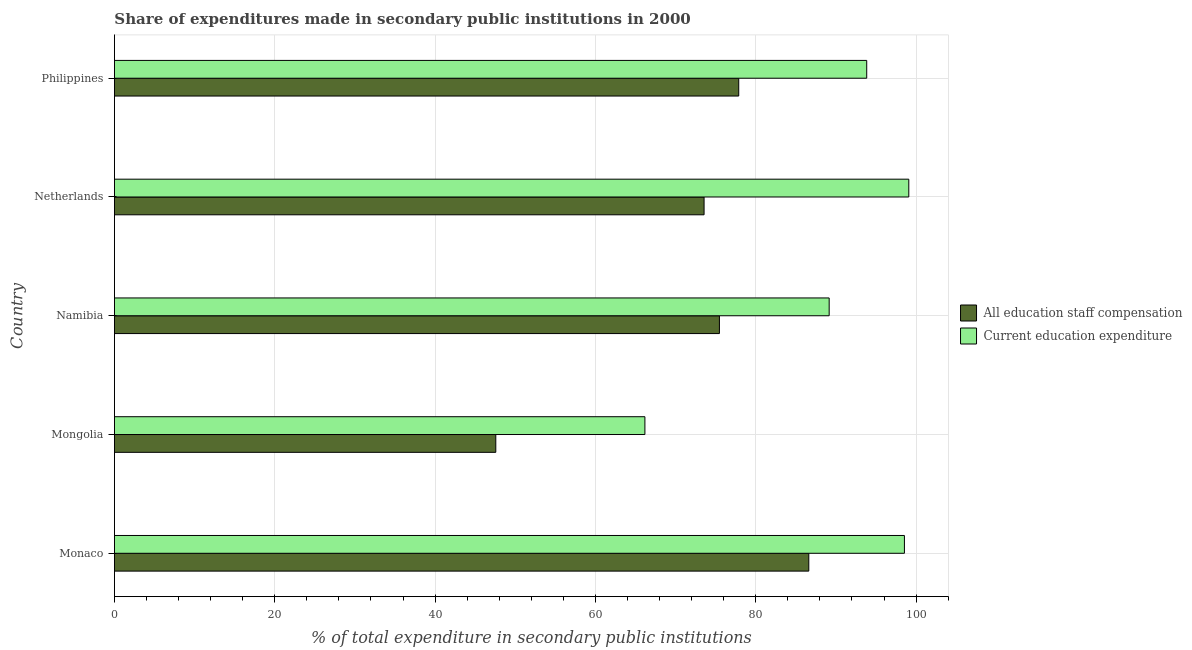How many different coloured bars are there?
Provide a short and direct response. 2. How many groups of bars are there?
Keep it short and to the point. 5. How many bars are there on the 1st tick from the top?
Make the answer very short. 2. How many bars are there on the 4th tick from the bottom?
Give a very brief answer. 2. What is the label of the 5th group of bars from the top?
Ensure brevity in your answer.  Monaco. What is the expenditure in education in Philippines?
Provide a succinct answer. 93.84. Across all countries, what is the maximum expenditure in staff compensation?
Your response must be concise. 86.62. Across all countries, what is the minimum expenditure in staff compensation?
Offer a very short reply. 47.57. In which country was the expenditure in staff compensation maximum?
Your response must be concise. Monaco. In which country was the expenditure in education minimum?
Provide a succinct answer. Mongolia. What is the total expenditure in staff compensation in the graph?
Your answer should be very brief. 361.08. What is the difference between the expenditure in staff compensation in Mongolia and that in Namibia?
Offer a terse response. -27.89. What is the difference between the expenditure in staff compensation in Mongolia and the expenditure in education in Netherlands?
Ensure brevity in your answer.  -51.52. What is the average expenditure in staff compensation per country?
Give a very brief answer. 72.22. What is the difference between the expenditure in education and expenditure in staff compensation in Mongolia?
Your answer should be very brief. 18.6. What is the ratio of the expenditure in staff compensation in Namibia to that in Netherlands?
Offer a very short reply. 1.03. Is the difference between the expenditure in staff compensation in Monaco and Netherlands greater than the difference between the expenditure in education in Monaco and Netherlands?
Keep it short and to the point. Yes. What is the difference between the highest and the second highest expenditure in staff compensation?
Give a very brief answer. 8.74. What is the difference between the highest and the lowest expenditure in staff compensation?
Provide a succinct answer. 39.04. In how many countries, is the expenditure in education greater than the average expenditure in education taken over all countries?
Offer a very short reply. 3. Is the sum of the expenditure in staff compensation in Netherlands and Philippines greater than the maximum expenditure in education across all countries?
Keep it short and to the point. Yes. What does the 1st bar from the top in Namibia represents?
Keep it short and to the point. Current education expenditure. What does the 1st bar from the bottom in Monaco represents?
Your response must be concise. All education staff compensation. Are all the bars in the graph horizontal?
Keep it short and to the point. Yes. How many countries are there in the graph?
Give a very brief answer. 5. What is the difference between two consecutive major ticks on the X-axis?
Offer a terse response. 20. Does the graph contain any zero values?
Give a very brief answer. No. Does the graph contain grids?
Make the answer very short. Yes. How many legend labels are there?
Ensure brevity in your answer.  2. How are the legend labels stacked?
Your answer should be compact. Vertical. What is the title of the graph?
Provide a succinct answer. Share of expenditures made in secondary public institutions in 2000. Does "Net National savings" appear as one of the legend labels in the graph?
Provide a short and direct response. No. What is the label or title of the X-axis?
Offer a terse response. % of total expenditure in secondary public institutions. What is the label or title of the Y-axis?
Offer a very short reply. Country. What is the % of total expenditure in secondary public institutions in All education staff compensation in Monaco?
Give a very brief answer. 86.62. What is the % of total expenditure in secondary public institutions in Current education expenditure in Monaco?
Make the answer very short. 98.54. What is the % of total expenditure in secondary public institutions of All education staff compensation in Mongolia?
Your response must be concise. 47.57. What is the % of total expenditure in secondary public institutions in Current education expenditure in Mongolia?
Your answer should be very brief. 66.17. What is the % of total expenditure in secondary public institutions in All education staff compensation in Namibia?
Offer a terse response. 75.47. What is the % of total expenditure in secondary public institutions in Current education expenditure in Namibia?
Provide a succinct answer. 89.16. What is the % of total expenditure in secondary public institutions of All education staff compensation in Netherlands?
Offer a very short reply. 73.55. What is the % of total expenditure in secondary public institutions in Current education expenditure in Netherlands?
Your response must be concise. 99.09. What is the % of total expenditure in secondary public institutions of All education staff compensation in Philippines?
Provide a short and direct response. 77.88. What is the % of total expenditure in secondary public institutions of Current education expenditure in Philippines?
Offer a terse response. 93.84. Across all countries, what is the maximum % of total expenditure in secondary public institutions in All education staff compensation?
Your answer should be compact. 86.62. Across all countries, what is the maximum % of total expenditure in secondary public institutions of Current education expenditure?
Offer a very short reply. 99.09. Across all countries, what is the minimum % of total expenditure in secondary public institutions of All education staff compensation?
Give a very brief answer. 47.57. Across all countries, what is the minimum % of total expenditure in secondary public institutions of Current education expenditure?
Give a very brief answer. 66.17. What is the total % of total expenditure in secondary public institutions of All education staff compensation in the graph?
Your answer should be very brief. 361.08. What is the total % of total expenditure in secondary public institutions in Current education expenditure in the graph?
Your response must be concise. 446.81. What is the difference between the % of total expenditure in secondary public institutions in All education staff compensation in Monaco and that in Mongolia?
Your response must be concise. 39.04. What is the difference between the % of total expenditure in secondary public institutions in Current education expenditure in Monaco and that in Mongolia?
Offer a terse response. 32.37. What is the difference between the % of total expenditure in secondary public institutions in All education staff compensation in Monaco and that in Namibia?
Give a very brief answer. 11.15. What is the difference between the % of total expenditure in secondary public institutions in Current education expenditure in Monaco and that in Namibia?
Your answer should be compact. 9.39. What is the difference between the % of total expenditure in secondary public institutions of All education staff compensation in Monaco and that in Netherlands?
Provide a succinct answer. 13.06. What is the difference between the % of total expenditure in secondary public institutions of Current education expenditure in Monaco and that in Netherlands?
Ensure brevity in your answer.  -0.55. What is the difference between the % of total expenditure in secondary public institutions in All education staff compensation in Monaco and that in Philippines?
Your response must be concise. 8.74. What is the difference between the % of total expenditure in secondary public institutions in Current education expenditure in Monaco and that in Philippines?
Make the answer very short. 4.7. What is the difference between the % of total expenditure in secondary public institutions in All education staff compensation in Mongolia and that in Namibia?
Give a very brief answer. -27.9. What is the difference between the % of total expenditure in secondary public institutions in Current education expenditure in Mongolia and that in Namibia?
Offer a terse response. -22.99. What is the difference between the % of total expenditure in secondary public institutions of All education staff compensation in Mongolia and that in Netherlands?
Your response must be concise. -25.98. What is the difference between the % of total expenditure in secondary public institutions of Current education expenditure in Mongolia and that in Netherlands?
Provide a short and direct response. -32.92. What is the difference between the % of total expenditure in secondary public institutions of All education staff compensation in Mongolia and that in Philippines?
Give a very brief answer. -30.3. What is the difference between the % of total expenditure in secondary public institutions of Current education expenditure in Mongolia and that in Philippines?
Ensure brevity in your answer.  -27.67. What is the difference between the % of total expenditure in secondary public institutions in All education staff compensation in Namibia and that in Netherlands?
Offer a terse response. 1.91. What is the difference between the % of total expenditure in secondary public institutions in Current education expenditure in Namibia and that in Netherlands?
Offer a very short reply. -9.93. What is the difference between the % of total expenditure in secondary public institutions of All education staff compensation in Namibia and that in Philippines?
Your response must be concise. -2.41. What is the difference between the % of total expenditure in secondary public institutions in Current education expenditure in Namibia and that in Philippines?
Offer a very short reply. -4.68. What is the difference between the % of total expenditure in secondary public institutions of All education staff compensation in Netherlands and that in Philippines?
Offer a terse response. -4.32. What is the difference between the % of total expenditure in secondary public institutions of Current education expenditure in Netherlands and that in Philippines?
Keep it short and to the point. 5.25. What is the difference between the % of total expenditure in secondary public institutions in All education staff compensation in Monaco and the % of total expenditure in secondary public institutions in Current education expenditure in Mongolia?
Your answer should be very brief. 20.44. What is the difference between the % of total expenditure in secondary public institutions of All education staff compensation in Monaco and the % of total expenditure in secondary public institutions of Current education expenditure in Namibia?
Your answer should be compact. -2.54. What is the difference between the % of total expenditure in secondary public institutions of All education staff compensation in Monaco and the % of total expenditure in secondary public institutions of Current education expenditure in Netherlands?
Give a very brief answer. -12.47. What is the difference between the % of total expenditure in secondary public institutions in All education staff compensation in Monaco and the % of total expenditure in secondary public institutions in Current education expenditure in Philippines?
Keep it short and to the point. -7.23. What is the difference between the % of total expenditure in secondary public institutions in All education staff compensation in Mongolia and the % of total expenditure in secondary public institutions in Current education expenditure in Namibia?
Give a very brief answer. -41.59. What is the difference between the % of total expenditure in secondary public institutions in All education staff compensation in Mongolia and the % of total expenditure in secondary public institutions in Current education expenditure in Netherlands?
Ensure brevity in your answer.  -51.52. What is the difference between the % of total expenditure in secondary public institutions in All education staff compensation in Mongolia and the % of total expenditure in secondary public institutions in Current education expenditure in Philippines?
Your answer should be very brief. -46.27. What is the difference between the % of total expenditure in secondary public institutions of All education staff compensation in Namibia and the % of total expenditure in secondary public institutions of Current education expenditure in Netherlands?
Your answer should be compact. -23.62. What is the difference between the % of total expenditure in secondary public institutions in All education staff compensation in Namibia and the % of total expenditure in secondary public institutions in Current education expenditure in Philippines?
Offer a very short reply. -18.37. What is the difference between the % of total expenditure in secondary public institutions of All education staff compensation in Netherlands and the % of total expenditure in secondary public institutions of Current education expenditure in Philippines?
Provide a short and direct response. -20.29. What is the average % of total expenditure in secondary public institutions in All education staff compensation per country?
Give a very brief answer. 72.22. What is the average % of total expenditure in secondary public institutions of Current education expenditure per country?
Your response must be concise. 89.36. What is the difference between the % of total expenditure in secondary public institutions in All education staff compensation and % of total expenditure in secondary public institutions in Current education expenditure in Monaco?
Offer a terse response. -11.93. What is the difference between the % of total expenditure in secondary public institutions in All education staff compensation and % of total expenditure in secondary public institutions in Current education expenditure in Mongolia?
Offer a very short reply. -18.6. What is the difference between the % of total expenditure in secondary public institutions in All education staff compensation and % of total expenditure in secondary public institutions in Current education expenditure in Namibia?
Provide a short and direct response. -13.69. What is the difference between the % of total expenditure in secondary public institutions of All education staff compensation and % of total expenditure in secondary public institutions of Current education expenditure in Netherlands?
Ensure brevity in your answer.  -25.54. What is the difference between the % of total expenditure in secondary public institutions of All education staff compensation and % of total expenditure in secondary public institutions of Current education expenditure in Philippines?
Your answer should be compact. -15.97. What is the ratio of the % of total expenditure in secondary public institutions of All education staff compensation in Monaco to that in Mongolia?
Ensure brevity in your answer.  1.82. What is the ratio of the % of total expenditure in secondary public institutions in Current education expenditure in Monaco to that in Mongolia?
Make the answer very short. 1.49. What is the ratio of the % of total expenditure in secondary public institutions in All education staff compensation in Monaco to that in Namibia?
Ensure brevity in your answer.  1.15. What is the ratio of the % of total expenditure in secondary public institutions of Current education expenditure in Monaco to that in Namibia?
Your answer should be compact. 1.11. What is the ratio of the % of total expenditure in secondary public institutions of All education staff compensation in Monaco to that in Netherlands?
Provide a succinct answer. 1.18. What is the ratio of the % of total expenditure in secondary public institutions in Current education expenditure in Monaco to that in Netherlands?
Offer a very short reply. 0.99. What is the ratio of the % of total expenditure in secondary public institutions in All education staff compensation in Monaco to that in Philippines?
Provide a short and direct response. 1.11. What is the ratio of the % of total expenditure in secondary public institutions of Current education expenditure in Monaco to that in Philippines?
Provide a succinct answer. 1.05. What is the ratio of the % of total expenditure in secondary public institutions of All education staff compensation in Mongolia to that in Namibia?
Keep it short and to the point. 0.63. What is the ratio of the % of total expenditure in secondary public institutions in Current education expenditure in Mongolia to that in Namibia?
Your response must be concise. 0.74. What is the ratio of the % of total expenditure in secondary public institutions of All education staff compensation in Mongolia to that in Netherlands?
Provide a succinct answer. 0.65. What is the ratio of the % of total expenditure in secondary public institutions in Current education expenditure in Mongolia to that in Netherlands?
Offer a terse response. 0.67. What is the ratio of the % of total expenditure in secondary public institutions of All education staff compensation in Mongolia to that in Philippines?
Offer a terse response. 0.61. What is the ratio of the % of total expenditure in secondary public institutions of Current education expenditure in Mongolia to that in Philippines?
Ensure brevity in your answer.  0.71. What is the ratio of the % of total expenditure in secondary public institutions in Current education expenditure in Namibia to that in Netherlands?
Provide a succinct answer. 0.9. What is the ratio of the % of total expenditure in secondary public institutions in All education staff compensation in Namibia to that in Philippines?
Your answer should be very brief. 0.97. What is the ratio of the % of total expenditure in secondary public institutions in Current education expenditure in Namibia to that in Philippines?
Your response must be concise. 0.95. What is the ratio of the % of total expenditure in secondary public institutions in All education staff compensation in Netherlands to that in Philippines?
Offer a terse response. 0.94. What is the ratio of the % of total expenditure in secondary public institutions in Current education expenditure in Netherlands to that in Philippines?
Offer a very short reply. 1.06. What is the difference between the highest and the second highest % of total expenditure in secondary public institutions in All education staff compensation?
Your answer should be very brief. 8.74. What is the difference between the highest and the second highest % of total expenditure in secondary public institutions in Current education expenditure?
Offer a terse response. 0.55. What is the difference between the highest and the lowest % of total expenditure in secondary public institutions of All education staff compensation?
Keep it short and to the point. 39.04. What is the difference between the highest and the lowest % of total expenditure in secondary public institutions of Current education expenditure?
Your response must be concise. 32.92. 